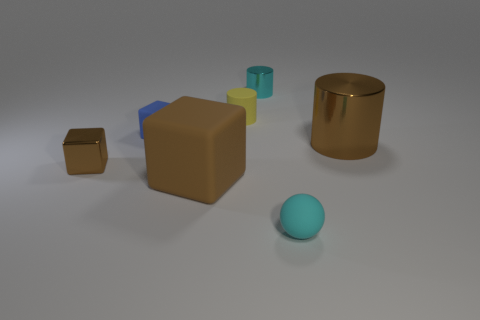Subtract all red cylinders. Subtract all gray spheres. How many cylinders are left? 3 Add 1 tiny cyan shiny things. How many objects exist? 8 Subtract all cylinders. How many objects are left? 4 Subtract 0 purple blocks. How many objects are left? 7 Subtract all small cyan rubber things. Subtract all brown cylinders. How many objects are left? 5 Add 6 tiny blue things. How many tiny blue things are left? 7 Add 4 big brown rubber objects. How many big brown rubber objects exist? 5 